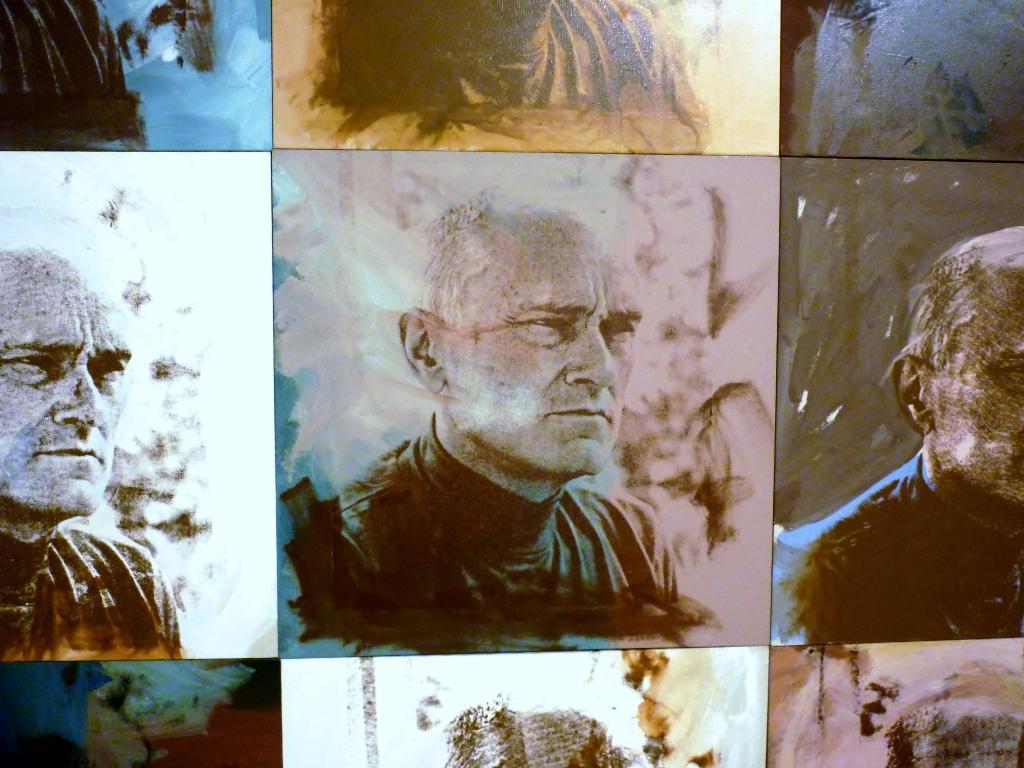In one or two sentences, can you explain what this image depicts? In this picture we can see collage frames. In every frame there is a man who is wearing black dress, but the background was in different colors. 